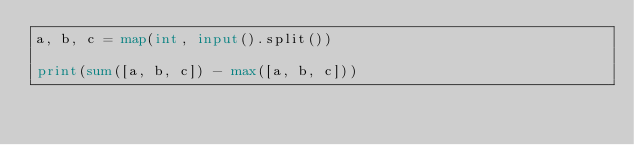Convert code to text. <code><loc_0><loc_0><loc_500><loc_500><_Python_>a, b, c = map(int, input().split())

print(sum([a, b, c]) - max([a, b, c]))</code> 